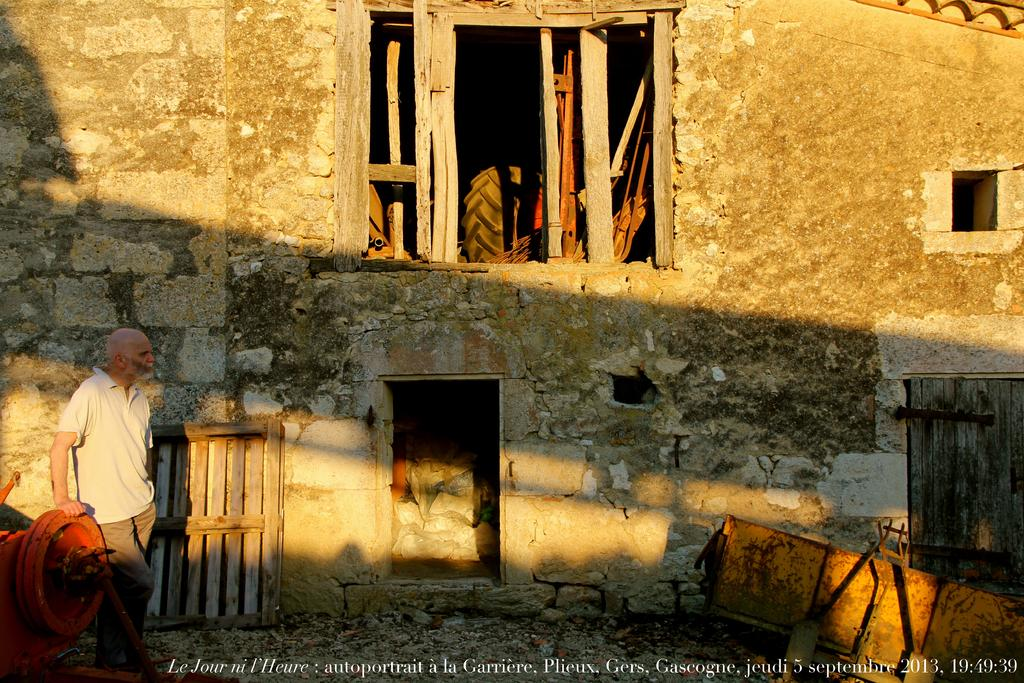<image>
Give a short and clear explanation of the subsequent image. A rural scene on which the words Le Jour are visible at the bottom. 